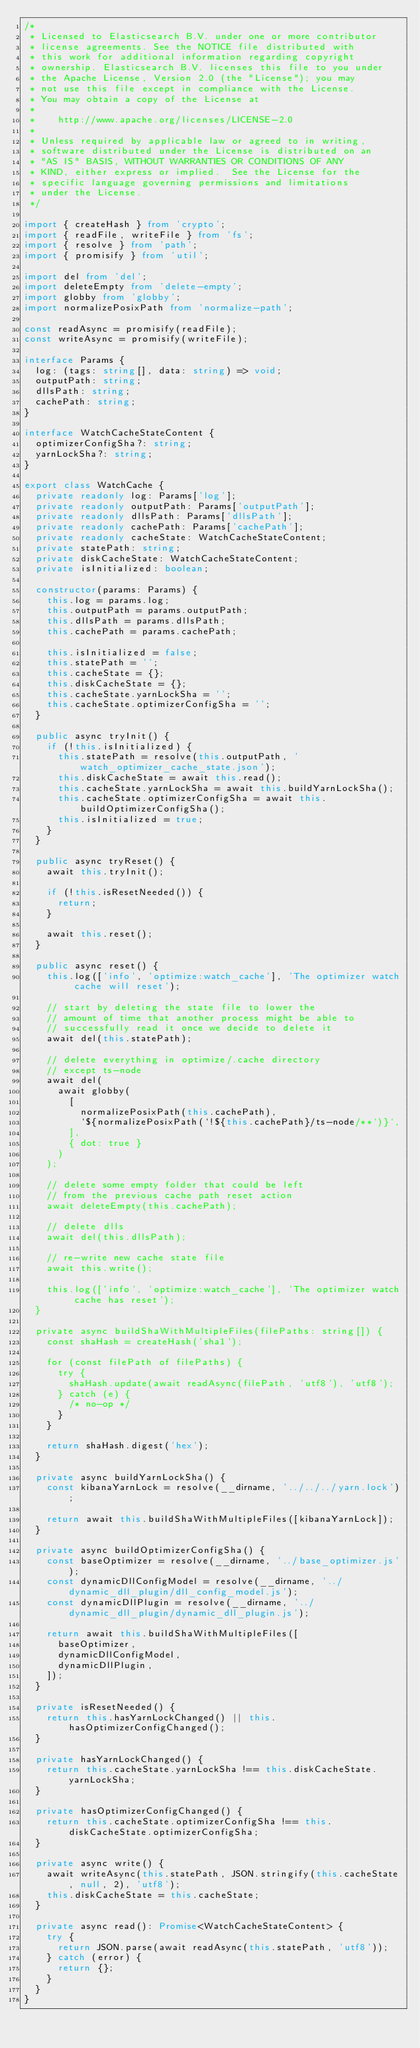Convert code to text. <code><loc_0><loc_0><loc_500><loc_500><_TypeScript_>/*
 * Licensed to Elasticsearch B.V. under one or more contributor
 * license agreements. See the NOTICE file distributed with
 * this work for additional information regarding copyright
 * ownership. Elasticsearch B.V. licenses this file to you under
 * the Apache License, Version 2.0 (the "License"); you may
 * not use this file except in compliance with the License.
 * You may obtain a copy of the License at
 *
 *    http://www.apache.org/licenses/LICENSE-2.0
 *
 * Unless required by applicable law or agreed to in writing,
 * software distributed under the License is distributed on an
 * "AS IS" BASIS, WITHOUT WARRANTIES OR CONDITIONS OF ANY
 * KIND, either express or implied.  See the License for the
 * specific language governing permissions and limitations
 * under the License.
 */

import { createHash } from 'crypto';
import { readFile, writeFile } from 'fs';
import { resolve } from 'path';
import { promisify } from 'util';

import del from 'del';
import deleteEmpty from 'delete-empty';
import globby from 'globby';
import normalizePosixPath from 'normalize-path';

const readAsync = promisify(readFile);
const writeAsync = promisify(writeFile);

interface Params {
  log: (tags: string[], data: string) => void;
  outputPath: string;
  dllsPath: string;
  cachePath: string;
}

interface WatchCacheStateContent {
  optimizerConfigSha?: string;
  yarnLockSha?: string;
}

export class WatchCache {
  private readonly log: Params['log'];
  private readonly outputPath: Params['outputPath'];
  private readonly dllsPath: Params['dllsPath'];
  private readonly cachePath: Params['cachePath'];
  private readonly cacheState: WatchCacheStateContent;
  private statePath: string;
  private diskCacheState: WatchCacheStateContent;
  private isInitialized: boolean;

  constructor(params: Params) {
    this.log = params.log;
    this.outputPath = params.outputPath;
    this.dllsPath = params.dllsPath;
    this.cachePath = params.cachePath;

    this.isInitialized = false;
    this.statePath = '';
    this.cacheState = {};
    this.diskCacheState = {};
    this.cacheState.yarnLockSha = '';
    this.cacheState.optimizerConfigSha = '';
  }

  public async tryInit() {
    if (!this.isInitialized) {
      this.statePath = resolve(this.outputPath, 'watch_optimizer_cache_state.json');
      this.diskCacheState = await this.read();
      this.cacheState.yarnLockSha = await this.buildYarnLockSha();
      this.cacheState.optimizerConfigSha = await this.buildOptimizerConfigSha();
      this.isInitialized = true;
    }
  }

  public async tryReset() {
    await this.tryInit();

    if (!this.isResetNeeded()) {
      return;
    }

    await this.reset();
  }

  public async reset() {
    this.log(['info', 'optimize:watch_cache'], 'The optimizer watch cache will reset');

    // start by deleting the state file to lower the
    // amount of time that another process might be able to
    // successfully read it once we decide to delete it
    await del(this.statePath);

    // delete everything in optimize/.cache directory
    // except ts-node
    await del(
      await globby(
        [
          normalizePosixPath(this.cachePath),
          `${normalizePosixPath(`!${this.cachePath}/ts-node/**`)}`,
        ],
        { dot: true }
      )
    );

    // delete some empty folder that could be left
    // from the previous cache path reset action
    await deleteEmpty(this.cachePath);

    // delete dlls
    await del(this.dllsPath);

    // re-write new cache state file
    await this.write();

    this.log(['info', 'optimize:watch_cache'], 'The optimizer watch cache has reset');
  }

  private async buildShaWithMultipleFiles(filePaths: string[]) {
    const shaHash = createHash('sha1');

    for (const filePath of filePaths) {
      try {
        shaHash.update(await readAsync(filePath, 'utf8'), 'utf8');
      } catch (e) {
        /* no-op */
      }
    }

    return shaHash.digest('hex');
  }

  private async buildYarnLockSha() {
    const kibanaYarnLock = resolve(__dirname, '../../../yarn.lock');

    return await this.buildShaWithMultipleFiles([kibanaYarnLock]);
  }

  private async buildOptimizerConfigSha() {
    const baseOptimizer = resolve(__dirname, '../base_optimizer.js');
    const dynamicDllConfigModel = resolve(__dirname, '../dynamic_dll_plugin/dll_config_model.js');
    const dynamicDllPlugin = resolve(__dirname, '../dynamic_dll_plugin/dynamic_dll_plugin.js');

    return await this.buildShaWithMultipleFiles([
      baseOptimizer,
      dynamicDllConfigModel,
      dynamicDllPlugin,
    ]);
  }

  private isResetNeeded() {
    return this.hasYarnLockChanged() || this.hasOptimizerConfigChanged();
  }

  private hasYarnLockChanged() {
    return this.cacheState.yarnLockSha !== this.diskCacheState.yarnLockSha;
  }

  private hasOptimizerConfigChanged() {
    return this.cacheState.optimizerConfigSha !== this.diskCacheState.optimizerConfigSha;
  }

  private async write() {
    await writeAsync(this.statePath, JSON.stringify(this.cacheState, null, 2), 'utf8');
    this.diskCacheState = this.cacheState;
  }

  private async read(): Promise<WatchCacheStateContent> {
    try {
      return JSON.parse(await readAsync(this.statePath, 'utf8'));
    } catch (error) {
      return {};
    }
  }
}
</code> 